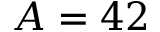Convert formula to latex. <formula><loc_0><loc_0><loc_500><loc_500>A = 4 2</formula> 